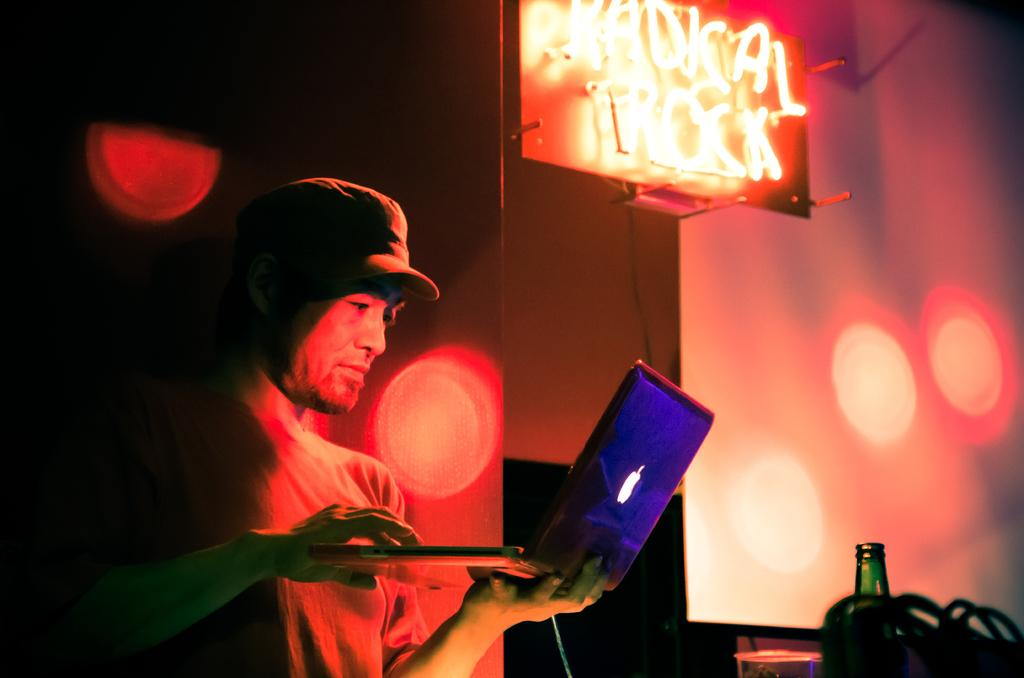Who is present in the image? There is a man in the image. What is the man holding in the image? The man is holding a laptop. What other objects can be seen in the image? There is a bottle, a projector screen, and a light board in the image. What type of knowledge can be heard coming from the room in the image? There is no reference to a room or any sounds in the image, so it's not possible to determine what type of knowledge might be heard. 